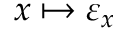Convert formula to latex. <formula><loc_0><loc_0><loc_500><loc_500>x \mapsto \varepsilon _ { x }</formula> 